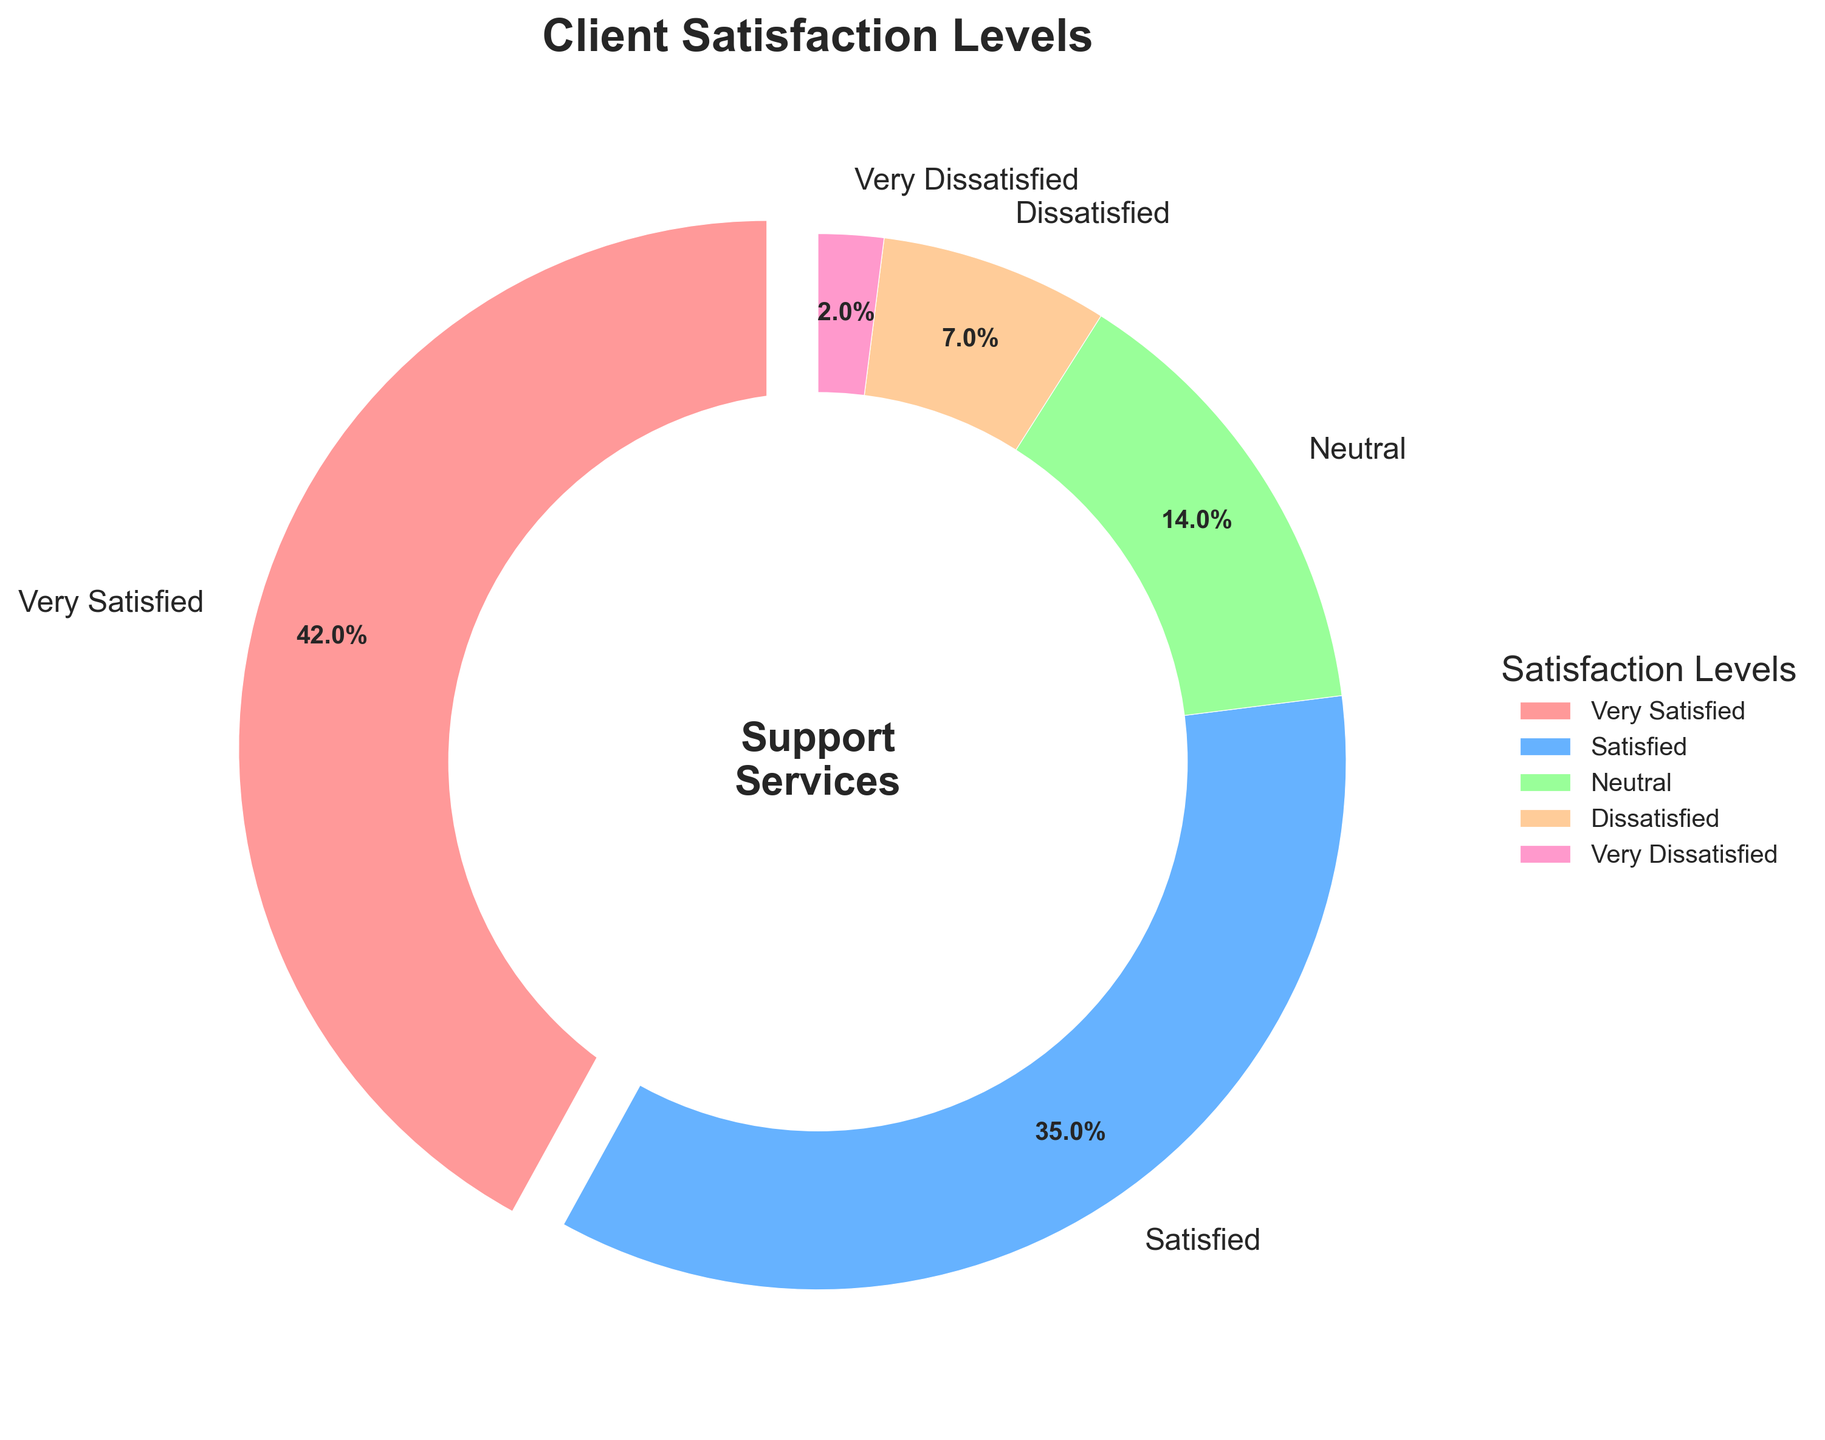What percentage of clients are either Very Satisfied or Satisfied? Add the percentages for "Very Satisfied" and "Satisfied". This is 42% (Very Satisfied) + 35% (Satisfied) = 77%
Answer: 77% Which satisfaction level has the lowest percentage? By looking at the percentages on the pie chart, we see that "Very Dissatisfied" has the lowest percentage at 2%
Answer: Very Dissatisfied How does the percentage of Neutral clients compare to that of Dissatisfied clients? "Neutral" has a percentage of 14%, while "Dissatisfied" has a percentage of 7%. Since 14% is greater than 7%, there are more Neutral clients than Dissatisfied clients
Answer: Neutral has double the percentage of Dissatisfied What is the total percentage of clients who are not satisfied (either Dissatisfied or Very Dissatisfied)? Add the percentages for "Dissatisfied" and "Very Dissatisfied". This is 7% (Dissatisfied) + 2% (Very Dissatisfied) = 9%
Answer: 9% Which satisfaction level has the largest wedge in the pie chart and what is its visual attribute? The largest wedge corresponds to the "Very Satisfied" level, which has a percentage of 42% and is visually the largest and is exploded slightly outwards compared to other wedges
Answer: Very Satisfied, largest and exploded How much higher is the percentage of Satisfied clients compared to Dissatisfied clients? Subtract the percentage of Dissatisfied clients from Satisfied clients. This is 35% (Satisfied) - 7% (Dissatisfied) = 28%
Answer: 28% What is the combined percentage of clients that are either Neutral or Dissatisfied? Add the percentages for "Neutral" and "Dissatisfied". This is 14% (Neutral) + 7% (Dissatisfied) = 21%
Answer: 21% If you combined the percentage of clients who are Very Dissatisfied and Dissatisfied, would it surpass the percentage of Neutral clients? Add the percentages for "Very Dissatisfied" and "Dissatisfied" which is 2% + 7% = 9%. Since 9% is less than 14% (Neutral), it does not surpass the percentage of Neutral clients
Answer: No If the "Neutral" percentage point were equally distributed to other categories, how much percentage would be added to each? The Neutral percentage is 14%, distributing this equally to 4 other categories results in 14% / 4 = 3.5% added to each category
Answer: 3.5% 